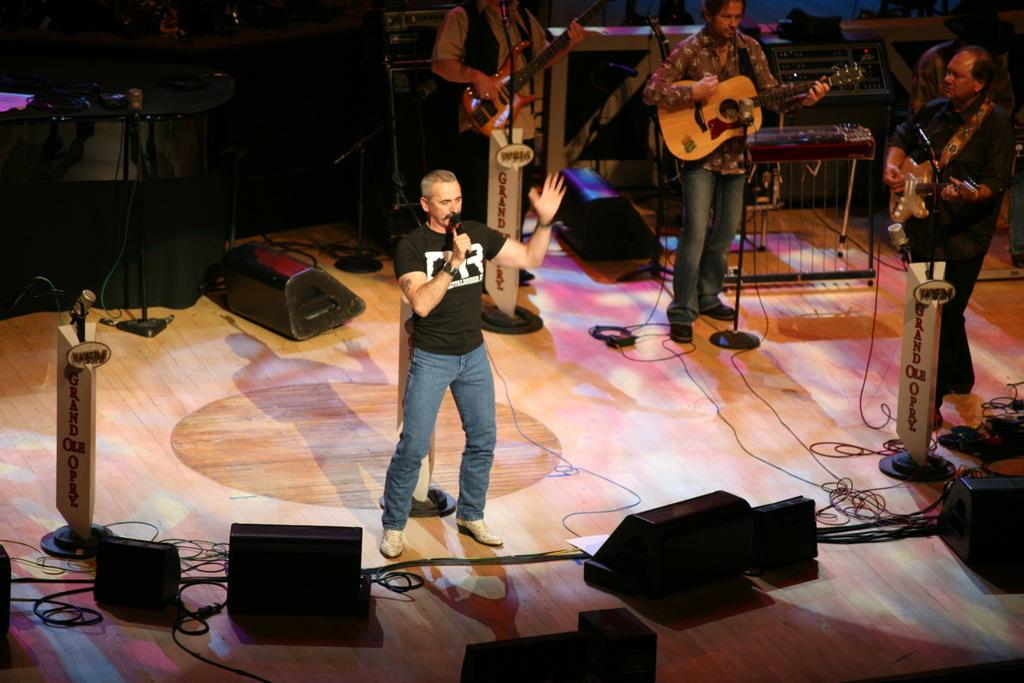How many people are in the image? There are four people in the image. What are three of the people holding? Three of the people are holding guitars. What is the fourth person holding? The fourth person is holding a microphone. What is the man holding the microphone doing? The man holding the microphone is singing a song. How many bees can be seen buzzing around the microphone in the image? There are no bees present in the image. What type of glove is the man holding the microphone wearing? The man holding the microphone is not wearing a glove in the image. 